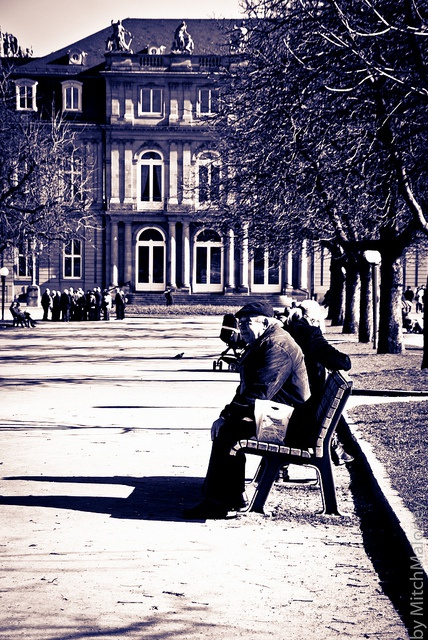Describe the objects in this image and their specific colors. I can see people in darkgray, black, white, navy, and purple tones, bench in darkgray, black, white, and navy tones, people in darkgray, black, white, navy, and gray tones, people in darkgray, black, white, purple, and navy tones, and people in darkgray, black, navy, purple, and lightgray tones in this image. 